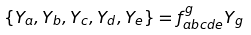Convert formula to latex. <formula><loc_0><loc_0><loc_500><loc_500>\{ Y _ { a } , Y _ { b } , Y _ { c } , Y _ { d } , Y _ { e } \} = f ^ { g } _ { a b c d e } Y _ { g }</formula> 